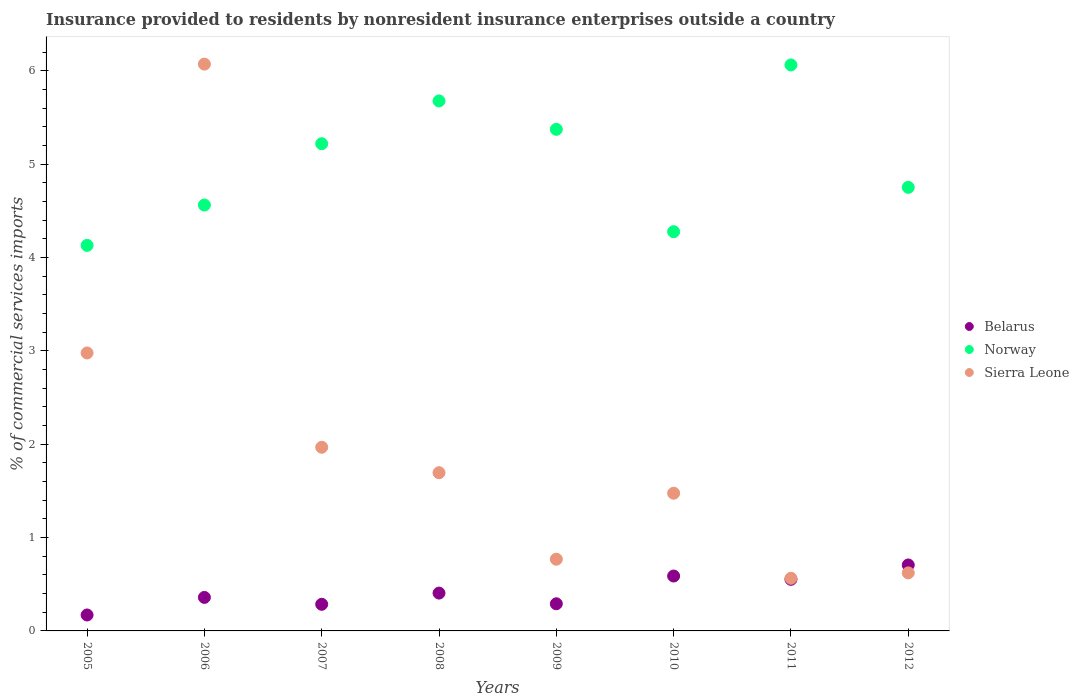Is the number of dotlines equal to the number of legend labels?
Make the answer very short. Yes. What is the Insurance provided to residents in Belarus in 2005?
Your answer should be compact. 0.17. Across all years, what is the maximum Insurance provided to residents in Sierra Leone?
Make the answer very short. 6.07. Across all years, what is the minimum Insurance provided to residents in Belarus?
Provide a succinct answer. 0.17. In which year was the Insurance provided to residents in Norway minimum?
Give a very brief answer. 2005. What is the total Insurance provided to residents in Norway in the graph?
Provide a succinct answer. 40.05. What is the difference between the Insurance provided to residents in Belarus in 2005 and that in 2006?
Give a very brief answer. -0.19. What is the difference between the Insurance provided to residents in Norway in 2006 and the Insurance provided to residents in Sierra Leone in 2005?
Your response must be concise. 1.58. What is the average Insurance provided to residents in Sierra Leone per year?
Keep it short and to the point. 2.02. In the year 2009, what is the difference between the Insurance provided to residents in Belarus and Insurance provided to residents in Sierra Leone?
Ensure brevity in your answer.  -0.48. What is the ratio of the Insurance provided to residents in Sierra Leone in 2005 to that in 2009?
Provide a succinct answer. 3.88. What is the difference between the highest and the second highest Insurance provided to residents in Norway?
Provide a succinct answer. 0.39. What is the difference between the highest and the lowest Insurance provided to residents in Norway?
Provide a short and direct response. 1.93. In how many years, is the Insurance provided to residents in Belarus greater than the average Insurance provided to residents in Belarus taken over all years?
Keep it short and to the point. 3. Is the sum of the Insurance provided to residents in Sierra Leone in 2007 and 2012 greater than the maximum Insurance provided to residents in Norway across all years?
Provide a succinct answer. No. Is the Insurance provided to residents in Norway strictly greater than the Insurance provided to residents in Sierra Leone over the years?
Your answer should be compact. No. How many years are there in the graph?
Offer a terse response. 8. Are the values on the major ticks of Y-axis written in scientific E-notation?
Your answer should be compact. No. Does the graph contain any zero values?
Keep it short and to the point. No. Does the graph contain grids?
Provide a succinct answer. No. Where does the legend appear in the graph?
Your response must be concise. Center right. How are the legend labels stacked?
Give a very brief answer. Vertical. What is the title of the graph?
Provide a succinct answer. Insurance provided to residents by nonresident insurance enterprises outside a country. Does "Guatemala" appear as one of the legend labels in the graph?
Your response must be concise. No. What is the label or title of the Y-axis?
Offer a terse response. % of commercial services imports. What is the % of commercial services imports in Belarus in 2005?
Your answer should be very brief. 0.17. What is the % of commercial services imports in Norway in 2005?
Give a very brief answer. 4.13. What is the % of commercial services imports of Sierra Leone in 2005?
Offer a very short reply. 2.98. What is the % of commercial services imports in Belarus in 2006?
Your response must be concise. 0.36. What is the % of commercial services imports in Norway in 2006?
Your response must be concise. 4.56. What is the % of commercial services imports in Sierra Leone in 2006?
Your response must be concise. 6.07. What is the % of commercial services imports in Belarus in 2007?
Make the answer very short. 0.29. What is the % of commercial services imports in Norway in 2007?
Ensure brevity in your answer.  5.22. What is the % of commercial services imports in Sierra Leone in 2007?
Keep it short and to the point. 1.97. What is the % of commercial services imports of Belarus in 2008?
Give a very brief answer. 0.41. What is the % of commercial services imports in Norway in 2008?
Your answer should be compact. 5.68. What is the % of commercial services imports in Sierra Leone in 2008?
Ensure brevity in your answer.  1.69. What is the % of commercial services imports in Belarus in 2009?
Make the answer very short. 0.29. What is the % of commercial services imports of Norway in 2009?
Offer a terse response. 5.37. What is the % of commercial services imports of Sierra Leone in 2009?
Your answer should be very brief. 0.77. What is the % of commercial services imports of Belarus in 2010?
Offer a terse response. 0.59. What is the % of commercial services imports in Norway in 2010?
Offer a very short reply. 4.28. What is the % of commercial services imports of Sierra Leone in 2010?
Give a very brief answer. 1.48. What is the % of commercial services imports of Belarus in 2011?
Ensure brevity in your answer.  0.55. What is the % of commercial services imports of Norway in 2011?
Offer a very short reply. 6.06. What is the % of commercial services imports in Sierra Leone in 2011?
Ensure brevity in your answer.  0.56. What is the % of commercial services imports in Belarus in 2012?
Your response must be concise. 0.71. What is the % of commercial services imports in Norway in 2012?
Ensure brevity in your answer.  4.75. What is the % of commercial services imports of Sierra Leone in 2012?
Offer a very short reply. 0.62. Across all years, what is the maximum % of commercial services imports in Belarus?
Make the answer very short. 0.71. Across all years, what is the maximum % of commercial services imports of Norway?
Give a very brief answer. 6.06. Across all years, what is the maximum % of commercial services imports in Sierra Leone?
Ensure brevity in your answer.  6.07. Across all years, what is the minimum % of commercial services imports of Belarus?
Provide a succinct answer. 0.17. Across all years, what is the minimum % of commercial services imports in Norway?
Provide a short and direct response. 4.13. Across all years, what is the minimum % of commercial services imports in Sierra Leone?
Offer a very short reply. 0.56. What is the total % of commercial services imports of Belarus in the graph?
Make the answer very short. 3.36. What is the total % of commercial services imports of Norway in the graph?
Ensure brevity in your answer.  40.05. What is the total % of commercial services imports of Sierra Leone in the graph?
Give a very brief answer. 16.14. What is the difference between the % of commercial services imports in Belarus in 2005 and that in 2006?
Give a very brief answer. -0.19. What is the difference between the % of commercial services imports in Norway in 2005 and that in 2006?
Provide a succinct answer. -0.43. What is the difference between the % of commercial services imports of Sierra Leone in 2005 and that in 2006?
Your response must be concise. -3.09. What is the difference between the % of commercial services imports in Belarus in 2005 and that in 2007?
Give a very brief answer. -0.11. What is the difference between the % of commercial services imports of Norway in 2005 and that in 2007?
Make the answer very short. -1.09. What is the difference between the % of commercial services imports of Belarus in 2005 and that in 2008?
Provide a succinct answer. -0.23. What is the difference between the % of commercial services imports of Norway in 2005 and that in 2008?
Your answer should be very brief. -1.55. What is the difference between the % of commercial services imports in Sierra Leone in 2005 and that in 2008?
Your answer should be compact. 1.28. What is the difference between the % of commercial services imports in Belarus in 2005 and that in 2009?
Keep it short and to the point. -0.12. What is the difference between the % of commercial services imports of Norway in 2005 and that in 2009?
Offer a terse response. -1.24. What is the difference between the % of commercial services imports in Sierra Leone in 2005 and that in 2009?
Keep it short and to the point. 2.21. What is the difference between the % of commercial services imports in Belarus in 2005 and that in 2010?
Give a very brief answer. -0.42. What is the difference between the % of commercial services imports of Norway in 2005 and that in 2010?
Your answer should be very brief. -0.15. What is the difference between the % of commercial services imports of Sierra Leone in 2005 and that in 2010?
Your response must be concise. 1.5. What is the difference between the % of commercial services imports in Belarus in 2005 and that in 2011?
Your answer should be very brief. -0.38. What is the difference between the % of commercial services imports of Norway in 2005 and that in 2011?
Offer a very short reply. -1.93. What is the difference between the % of commercial services imports of Sierra Leone in 2005 and that in 2011?
Ensure brevity in your answer.  2.41. What is the difference between the % of commercial services imports of Belarus in 2005 and that in 2012?
Ensure brevity in your answer.  -0.54. What is the difference between the % of commercial services imports in Norway in 2005 and that in 2012?
Keep it short and to the point. -0.62. What is the difference between the % of commercial services imports in Sierra Leone in 2005 and that in 2012?
Give a very brief answer. 2.36. What is the difference between the % of commercial services imports in Belarus in 2006 and that in 2007?
Your answer should be very brief. 0.07. What is the difference between the % of commercial services imports in Norway in 2006 and that in 2007?
Provide a short and direct response. -0.66. What is the difference between the % of commercial services imports in Sierra Leone in 2006 and that in 2007?
Ensure brevity in your answer.  4.1. What is the difference between the % of commercial services imports in Belarus in 2006 and that in 2008?
Provide a succinct answer. -0.05. What is the difference between the % of commercial services imports of Norway in 2006 and that in 2008?
Keep it short and to the point. -1.12. What is the difference between the % of commercial services imports of Sierra Leone in 2006 and that in 2008?
Provide a short and direct response. 4.38. What is the difference between the % of commercial services imports of Belarus in 2006 and that in 2009?
Your answer should be very brief. 0.07. What is the difference between the % of commercial services imports in Norway in 2006 and that in 2009?
Your response must be concise. -0.81. What is the difference between the % of commercial services imports in Sierra Leone in 2006 and that in 2009?
Provide a short and direct response. 5.3. What is the difference between the % of commercial services imports of Belarus in 2006 and that in 2010?
Offer a very short reply. -0.23. What is the difference between the % of commercial services imports of Norway in 2006 and that in 2010?
Your answer should be compact. 0.29. What is the difference between the % of commercial services imports in Sierra Leone in 2006 and that in 2010?
Provide a short and direct response. 4.6. What is the difference between the % of commercial services imports in Belarus in 2006 and that in 2011?
Your answer should be very brief. -0.19. What is the difference between the % of commercial services imports in Norway in 2006 and that in 2011?
Your answer should be compact. -1.5. What is the difference between the % of commercial services imports in Sierra Leone in 2006 and that in 2011?
Offer a terse response. 5.51. What is the difference between the % of commercial services imports of Belarus in 2006 and that in 2012?
Provide a succinct answer. -0.35. What is the difference between the % of commercial services imports of Norway in 2006 and that in 2012?
Give a very brief answer. -0.19. What is the difference between the % of commercial services imports in Sierra Leone in 2006 and that in 2012?
Provide a short and direct response. 5.45. What is the difference between the % of commercial services imports of Belarus in 2007 and that in 2008?
Provide a short and direct response. -0.12. What is the difference between the % of commercial services imports in Norway in 2007 and that in 2008?
Offer a very short reply. -0.46. What is the difference between the % of commercial services imports of Sierra Leone in 2007 and that in 2008?
Your response must be concise. 0.27. What is the difference between the % of commercial services imports in Belarus in 2007 and that in 2009?
Your answer should be very brief. -0.01. What is the difference between the % of commercial services imports in Norway in 2007 and that in 2009?
Your answer should be compact. -0.15. What is the difference between the % of commercial services imports in Sierra Leone in 2007 and that in 2009?
Your answer should be compact. 1.2. What is the difference between the % of commercial services imports in Belarus in 2007 and that in 2010?
Keep it short and to the point. -0.3. What is the difference between the % of commercial services imports of Norway in 2007 and that in 2010?
Provide a short and direct response. 0.94. What is the difference between the % of commercial services imports in Sierra Leone in 2007 and that in 2010?
Offer a very short reply. 0.49. What is the difference between the % of commercial services imports in Belarus in 2007 and that in 2011?
Your answer should be very brief. -0.27. What is the difference between the % of commercial services imports of Norway in 2007 and that in 2011?
Your response must be concise. -0.84. What is the difference between the % of commercial services imports of Sierra Leone in 2007 and that in 2011?
Provide a short and direct response. 1.4. What is the difference between the % of commercial services imports in Belarus in 2007 and that in 2012?
Give a very brief answer. -0.42. What is the difference between the % of commercial services imports of Norway in 2007 and that in 2012?
Your answer should be compact. 0.47. What is the difference between the % of commercial services imports in Sierra Leone in 2007 and that in 2012?
Your response must be concise. 1.35. What is the difference between the % of commercial services imports of Belarus in 2008 and that in 2009?
Your response must be concise. 0.11. What is the difference between the % of commercial services imports in Norway in 2008 and that in 2009?
Provide a succinct answer. 0.3. What is the difference between the % of commercial services imports of Sierra Leone in 2008 and that in 2009?
Provide a succinct answer. 0.93. What is the difference between the % of commercial services imports of Belarus in 2008 and that in 2010?
Make the answer very short. -0.18. What is the difference between the % of commercial services imports in Norway in 2008 and that in 2010?
Offer a very short reply. 1.4. What is the difference between the % of commercial services imports in Sierra Leone in 2008 and that in 2010?
Your answer should be compact. 0.22. What is the difference between the % of commercial services imports of Belarus in 2008 and that in 2011?
Provide a succinct answer. -0.15. What is the difference between the % of commercial services imports in Norway in 2008 and that in 2011?
Your answer should be very brief. -0.39. What is the difference between the % of commercial services imports of Sierra Leone in 2008 and that in 2011?
Make the answer very short. 1.13. What is the difference between the % of commercial services imports of Belarus in 2008 and that in 2012?
Offer a very short reply. -0.3. What is the difference between the % of commercial services imports in Norway in 2008 and that in 2012?
Provide a succinct answer. 0.93. What is the difference between the % of commercial services imports of Sierra Leone in 2008 and that in 2012?
Your response must be concise. 1.07. What is the difference between the % of commercial services imports of Belarus in 2009 and that in 2010?
Your response must be concise. -0.3. What is the difference between the % of commercial services imports of Norway in 2009 and that in 2010?
Your response must be concise. 1.1. What is the difference between the % of commercial services imports of Sierra Leone in 2009 and that in 2010?
Make the answer very short. -0.71. What is the difference between the % of commercial services imports in Belarus in 2009 and that in 2011?
Ensure brevity in your answer.  -0.26. What is the difference between the % of commercial services imports in Norway in 2009 and that in 2011?
Give a very brief answer. -0.69. What is the difference between the % of commercial services imports in Sierra Leone in 2009 and that in 2011?
Keep it short and to the point. 0.2. What is the difference between the % of commercial services imports in Belarus in 2009 and that in 2012?
Provide a short and direct response. -0.42. What is the difference between the % of commercial services imports in Norway in 2009 and that in 2012?
Your answer should be very brief. 0.62. What is the difference between the % of commercial services imports in Sierra Leone in 2009 and that in 2012?
Your response must be concise. 0.15. What is the difference between the % of commercial services imports in Belarus in 2010 and that in 2011?
Keep it short and to the point. 0.04. What is the difference between the % of commercial services imports of Norway in 2010 and that in 2011?
Ensure brevity in your answer.  -1.79. What is the difference between the % of commercial services imports of Sierra Leone in 2010 and that in 2011?
Your answer should be very brief. 0.91. What is the difference between the % of commercial services imports of Belarus in 2010 and that in 2012?
Make the answer very short. -0.12. What is the difference between the % of commercial services imports of Norway in 2010 and that in 2012?
Ensure brevity in your answer.  -0.47. What is the difference between the % of commercial services imports of Sierra Leone in 2010 and that in 2012?
Your answer should be compact. 0.85. What is the difference between the % of commercial services imports in Belarus in 2011 and that in 2012?
Make the answer very short. -0.15. What is the difference between the % of commercial services imports in Norway in 2011 and that in 2012?
Ensure brevity in your answer.  1.31. What is the difference between the % of commercial services imports in Sierra Leone in 2011 and that in 2012?
Provide a succinct answer. -0.06. What is the difference between the % of commercial services imports in Belarus in 2005 and the % of commercial services imports in Norway in 2006?
Keep it short and to the point. -4.39. What is the difference between the % of commercial services imports of Belarus in 2005 and the % of commercial services imports of Sierra Leone in 2006?
Your answer should be very brief. -5.9. What is the difference between the % of commercial services imports of Norway in 2005 and the % of commercial services imports of Sierra Leone in 2006?
Provide a short and direct response. -1.94. What is the difference between the % of commercial services imports in Belarus in 2005 and the % of commercial services imports in Norway in 2007?
Provide a succinct answer. -5.05. What is the difference between the % of commercial services imports of Belarus in 2005 and the % of commercial services imports of Sierra Leone in 2007?
Your response must be concise. -1.8. What is the difference between the % of commercial services imports of Norway in 2005 and the % of commercial services imports of Sierra Leone in 2007?
Keep it short and to the point. 2.16. What is the difference between the % of commercial services imports in Belarus in 2005 and the % of commercial services imports in Norway in 2008?
Give a very brief answer. -5.51. What is the difference between the % of commercial services imports in Belarus in 2005 and the % of commercial services imports in Sierra Leone in 2008?
Offer a very short reply. -1.52. What is the difference between the % of commercial services imports of Norway in 2005 and the % of commercial services imports of Sierra Leone in 2008?
Offer a terse response. 2.44. What is the difference between the % of commercial services imports of Belarus in 2005 and the % of commercial services imports of Norway in 2009?
Provide a succinct answer. -5.2. What is the difference between the % of commercial services imports in Belarus in 2005 and the % of commercial services imports in Sierra Leone in 2009?
Make the answer very short. -0.6. What is the difference between the % of commercial services imports of Norway in 2005 and the % of commercial services imports of Sierra Leone in 2009?
Offer a very short reply. 3.36. What is the difference between the % of commercial services imports of Belarus in 2005 and the % of commercial services imports of Norway in 2010?
Ensure brevity in your answer.  -4.11. What is the difference between the % of commercial services imports in Belarus in 2005 and the % of commercial services imports in Sierra Leone in 2010?
Keep it short and to the point. -1.3. What is the difference between the % of commercial services imports in Norway in 2005 and the % of commercial services imports in Sierra Leone in 2010?
Give a very brief answer. 2.65. What is the difference between the % of commercial services imports in Belarus in 2005 and the % of commercial services imports in Norway in 2011?
Ensure brevity in your answer.  -5.89. What is the difference between the % of commercial services imports in Belarus in 2005 and the % of commercial services imports in Sierra Leone in 2011?
Keep it short and to the point. -0.39. What is the difference between the % of commercial services imports in Norway in 2005 and the % of commercial services imports in Sierra Leone in 2011?
Give a very brief answer. 3.57. What is the difference between the % of commercial services imports of Belarus in 2005 and the % of commercial services imports of Norway in 2012?
Provide a short and direct response. -4.58. What is the difference between the % of commercial services imports in Belarus in 2005 and the % of commercial services imports in Sierra Leone in 2012?
Your answer should be compact. -0.45. What is the difference between the % of commercial services imports of Norway in 2005 and the % of commercial services imports of Sierra Leone in 2012?
Offer a terse response. 3.51. What is the difference between the % of commercial services imports in Belarus in 2006 and the % of commercial services imports in Norway in 2007?
Your response must be concise. -4.86. What is the difference between the % of commercial services imports in Belarus in 2006 and the % of commercial services imports in Sierra Leone in 2007?
Provide a succinct answer. -1.61. What is the difference between the % of commercial services imports of Norway in 2006 and the % of commercial services imports of Sierra Leone in 2007?
Give a very brief answer. 2.59. What is the difference between the % of commercial services imports in Belarus in 2006 and the % of commercial services imports in Norway in 2008?
Give a very brief answer. -5.32. What is the difference between the % of commercial services imports in Belarus in 2006 and the % of commercial services imports in Sierra Leone in 2008?
Offer a terse response. -1.34. What is the difference between the % of commercial services imports in Norway in 2006 and the % of commercial services imports in Sierra Leone in 2008?
Provide a succinct answer. 2.87. What is the difference between the % of commercial services imports of Belarus in 2006 and the % of commercial services imports of Norway in 2009?
Ensure brevity in your answer.  -5.01. What is the difference between the % of commercial services imports in Belarus in 2006 and the % of commercial services imports in Sierra Leone in 2009?
Your answer should be compact. -0.41. What is the difference between the % of commercial services imports in Norway in 2006 and the % of commercial services imports in Sierra Leone in 2009?
Provide a succinct answer. 3.79. What is the difference between the % of commercial services imports in Belarus in 2006 and the % of commercial services imports in Norway in 2010?
Ensure brevity in your answer.  -3.92. What is the difference between the % of commercial services imports in Belarus in 2006 and the % of commercial services imports in Sierra Leone in 2010?
Provide a succinct answer. -1.12. What is the difference between the % of commercial services imports in Norway in 2006 and the % of commercial services imports in Sierra Leone in 2010?
Provide a succinct answer. 3.09. What is the difference between the % of commercial services imports of Belarus in 2006 and the % of commercial services imports of Norway in 2011?
Keep it short and to the point. -5.7. What is the difference between the % of commercial services imports in Belarus in 2006 and the % of commercial services imports in Sierra Leone in 2011?
Your answer should be compact. -0.2. What is the difference between the % of commercial services imports in Norway in 2006 and the % of commercial services imports in Sierra Leone in 2011?
Give a very brief answer. 4. What is the difference between the % of commercial services imports of Belarus in 2006 and the % of commercial services imports of Norway in 2012?
Make the answer very short. -4.39. What is the difference between the % of commercial services imports of Belarus in 2006 and the % of commercial services imports of Sierra Leone in 2012?
Make the answer very short. -0.26. What is the difference between the % of commercial services imports of Norway in 2006 and the % of commercial services imports of Sierra Leone in 2012?
Keep it short and to the point. 3.94. What is the difference between the % of commercial services imports of Belarus in 2007 and the % of commercial services imports of Norway in 2008?
Make the answer very short. -5.39. What is the difference between the % of commercial services imports in Belarus in 2007 and the % of commercial services imports in Sierra Leone in 2008?
Your response must be concise. -1.41. What is the difference between the % of commercial services imports in Norway in 2007 and the % of commercial services imports in Sierra Leone in 2008?
Offer a very short reply. 3.52. What is the difference between the % of commercial services imports in Belarus in 2007 and the % of commercial services imports in Norway in 2009?
Give a very brief answer. -5.09. What is the difference between the % of commercial services imports in Belarus in 2007 and the % of commercial services imports in Sierra Leone in 2009?
Your response must be concise. -0.48. What is the difference between the % of commercial services imports of Norway in 2007 and the % of commercial services imports of Sierra Leone in 2009?
Offer a terse response. 4.45. What is the difference between the % of commercial services imports of Belarus in 2007 and the % of commercial services imports of Norway in 2010?
Give a very brief answer. -3.99. What is the difference between the % of commercial services imports of Belarus in 2007 and the % of commercial services imports of Sierra Leone in 2010?
Provide a succinct answer. -1.19. What is the difference between the % of commercial services imports in Norway in 2007 and the % of commercial services imports in Sierra Leone in 2010?
Provide a short and direct response. 3.74. What is the difference between the % of commercial services imports in Belarus in 2007 and the % of commercial services imports in Norway in 2011?
Provide a short and direct response. -5.78. What is the difference between the % of commercial services imports in Belarus in 2007 and the % of commercial services imports in Sierra Leone in 2011?
Make the answer very short. -0.28. What is the difference between the % of commercial services imports in Norway in 2007 and the % of commercial services imports in Sierra Leone in 2011?
Offer a terse response. 4.66. What is the difference between the % of commercial services imports of Belarus in 2007 and the % of commercial services imports of Norway in 2012?
Keep it short and to the point. -4.47. What is the difference between the % of commercial services imports of Belarus in 2007 and the % of commercial services imports of Sierra Leone in 2012?
Offer a very short reply. -0.34. What is the difference between the % of commercial services imports in Norway in 2007 and the % of commercial services imports in Sierra Leone in 2012?
Your response must be concise. 4.6. What is the difference between the % of commercial services imports in Belarus in 2008 and the % of commercial services imports in Norway in 2009?
Give a very brief answer. -4.97. What is the difference between the % of commercial services imports in Belarus in 2008 and the % of commercial services imports in Sierra Leone in 2009?
Offer a very short reply. -0.36. What is the difference between the % of commercial services imports of Norway in 2008 and the % of commercial services imports of Sierra Leone in 2009?
Offer a very short reply. 4.91. What is the difference between the % of commercial services imports of Belarus in 2008 and the % of commercial services imports of Norway in 2010?
Provide a short and direct response. -3.87. What is the difference between the % of commercial services imports of Belarus in 2008 and the % of commercial services imports of Sierra Leone in 2010?
Offer a very short reply. -1.07. What is the difference between the % of commercial services imports in Norway in 2008 and the % of commercial services imports in Sierra Leone in 2010?
Keep it short and to the point. 4.2. What is the difference between the % of commercial services imports in Belarus in 2008 and the % of commercial services imports in Norway in 2011?
Your answer should be very brief. -5.66. What is the difference between the % of commercial services imports of Belarus in 2008 and the % of commercial services imports of Sierra Leone in 2011?
Provide a short and direct response. -0.16. What is the difference between the % of commercial services imports of Norway in 2008 and the % of commercial services imports of Sierra Leone in 2011?
Offer a very short reply. 5.11. What is the difference between the % of commercial services imports in Belarus in 2008 and the % of commercial services imports in Norway in 2012?
Offer a very short reply. -4.35. What is the difference between the % of commercial services imports in Belarus in 2008 and the % of commercial services imports in Sierra Leone in 2012?
Your response must be concise. -0.22. What is the difference between the % of commercial services imports in Norway in 2008 and the % of commercial services imports in Sierra Leone in 2012?
Provide a short and direct response. 5.06. What is the difference between the % of commercial services imports of Belarus in 2009 and the % of commercial services imports of Norway in 2010?
Give a very brief answer. -3.99. What is the difference between the % of commercial services imports in Belarus in 2009 and the % of commercial services imports in Sierra Leone in 2010?
Your answer should be compact. -1.18. What is the difference between the % of commercial services imports of Norway in 2009 and the % of commercial services imports of Sierra Leone in 2010?
Offer a terse response. 3.9. What is the difference between the % of commercial services imports in Belarus in 2009 and the % of commercial services imports in Norway in 2011?
Provide a succinct answer. -5.77. What is the difference between the % of commercial services imports in Belarus in 2009 and the % of commercial services imports in Sierra Leone in 2011?
Your answer should be very brief. -0.27. What is the difference between the % of commercial services imports in Norway in 2009 and the % of commercial services imports in Sierra Leone in 2011?
Your answer should be compact. 4.81. What is the difference between the % of commercial services imports in Belarus in 2009 and the % of commercial services imports in Norway in 2012?
Make the answer very short. -4.46. What is the difference between the % of commercial services imports in Belarus in 2009 and the % of commercial services imports in Sierra Leone in 2012?
Offer a terse response. -0.33. What is the difference between the % of commercial services imports of Norway in 2009 and the % of commercial services imports of Sierra Leone in 2012?
Offer a terse response. 4.75. What is the difference between the % of commercial services imports in Belarus in 2010 and the % of commercial services imports in Norway in 2011?
Offer a terse response. -5.48. What is the difference between the % of commercial services imports in Belarus in 2010 and the % of commercial services imports in Sierra Leone in 2011?
Keep it short and to the point. 0.02. What is the difference between the % of commercial services imports of Norway in 2010 and the % of commercial services imports of Sierra Leone in 2011?
Ensure brevity in your answer.  3.71. What is the difference between the % of commercial services imports in Belarus in 2010 and the % of commercial services imports in Norway in 2012?
Ensure brevity in your answer.  -4.16. What is the difference between the % of commercial services imports of Belarus in 2010 and the % of commercial services imports of Sierra Leone in 2012?
Offer a very short reply. -0.03. What is the difference between the % of commercial services imports in Norway in 2010 and the % of commercial services imports in Sierra Leone in 2012?
Your answer should be very brief. 3.65. What is the difference between the % of commercial services imports of Belarus in 2011 and the % of commercial services imports of Norway in 2012?
Provide a short and direct response. -4.2. What is the difference between the % of commercial services imports in Belarus in 2011 and the % of commercial services imports in Sierra Leone in 2012?
Your answer should be compact. -0.07. What is the difference between the % of commercial services imports in Norway in 2011 and the % of commercial services imports in Sierra Leone in 2012?
Offer a very short reply. 5.44. What is the average % of commercial services imports of Belarus per year?
Give a very brief answer. 0.42. What is the average % of commercial services imports in Norway per year?
Ensure brevity in your answer.  5.01. What is the average % of commercial services imports of Sierra Leone per year?
Keep it short and to the point. 2.02. In the year 2005, what is the difference between the % of commercial services imports of Belarus and % of commercial services imports of Norway?
Offer a terse response. -3.96. In the year 2005, what is the difference between the % of commercial services imports in Belarus and % of commercial services imports in Sierra Leone?
Your response must be concise. -2.81. In the year 2005, what is the difference between the % of commercial services imports in Norway and % of commercial services imports in Sierra Leone?
Make the answer very short. 1.15. In the year 2006, what is the difference between the % of commercial services imports in Belarus and % of commercial services imports in Norway?
Your answer should be compact. -4.2. In the year 2006, what is the difference between the % of commercial services imports in Belarus and % of commercial services imports in Sierra Leone?
Your answer should be compact. -5.71. In the year 2006, what is the difference between the % of commercial services imports of Norway and % of commercial services imports of Sierra Leone?
Your answer should be very brief. -1.51. In the year 2007, what is the difference between the % of commercial services imports of Belarus and % of commercial services imports of Norway?
Keep it short and to the point. -4.93. In the year 2007, what is the difference between the % of commercial services imports in Belarus and % of commercial services imports in Sierra Leone?
Offer a very short reply. -1.68. In the year 2007, what is the difference between the % of commercial services imports in Norway and % of commercial services imports in Sierra Leone?
Your answer should be very brief. 3.25. In the year 2008, what is the difference between the % of commercial services imports of Belarus and % of commercial services imports of Norway?
Offer a very short reply. -5.27. In the year 2008, what is the difference between the % of commercial services imports of Belarus and % of commercial services imports of Sierra Leone?
Provide a short and direct response. -1.29. In the year 2008, what is the difference between the % of commercial services imports of Norway and % of commercial services imports of Sierra Leone?
Your answer should be compact. 3.98. In the year 2009, what is the difference between the % of commercial services imports of Belarus and % of commercial services imports of Norway?
Provide a succinct answer. -5.08. In the year 2009, what is the difference between the % of commercial services imports in Belarus and % of commercial services imports in Sierra Leone?
Your answer should be compact. -0.48. In the year 2009, what is the difference between the % of commercial services imports of Norway and % of commercial services imports of Sierra Leone?
Your answer should be very brief. 4.6. In the year 2010, what is the difference between the % of commercial services imports in Belarus and % of commercial services imports in Norway?
Make the answer very short. -3.69. In the year 2010, what is the difference between the % of commercial services imports in Belarus and % of commercial services imports in Sierra Leone?
Keep it short and to the point. -0.89. In the year 2010, what is the difference between the % of commercial services imports in Norway and % of commercial services imports in Sierra Leone?
Offer a very short reply. 2.8. In the year 2011, what is the difference between the % of commercial services imports of Belarus and % of commercial services imports of Norway?
Provide a succinct answer. -5.51. In the year 2011, what is the difference between the % of commercial services imports of Belarus and % of commercial services imports of Sierra Leone?
Offer a terse response. -0.01. In the year 2011, what is the difference between the % of commercial services imports of Norway and % of commercial services imports of Sierra Leone?
Your answer should be compact. 5.5. In the year 2012, what is the difference between the % of commercial services imports of Belarus and % of commercial services imports of Norway?
Keep it short and to the point. -4.05. In the year 2012, what is the difference between the % of commercial services imports in Belarus and % of commercial services imports in Sierra Leone?
Your answer should be compact. 0.08. In the year 2012, what is the difference between the % of commercial services imports of Norway and % of commercial services imports of Sierra Leone?
Your response must be concise. 4.13. What is the ratio of the % of commercial services imports in Belarus in 2005 to that in 2006?
Give a very brief answer. 0.48. What is the ratio of the % of commercial services imports of Norway in 2005 to that in 2006?
Keep it short and to the point. 0.91. What is the ratio of the % of commercial services imports in Sierra Leone in 2005 to that in 2006?
Provide a short and direct response. 0.49. What is the ratio of the % of commercial services imports of Belarus in 2005 to that in 2007?
Provide a succinct answer. 0.6. What is the ratio of the % of commercial services imports in Norway in 2005 to that in 2007?
Offer a very short reply. 0.79. What is the ratio of the % of commercial services imports in Sierra Leone in 2005 to that in 2007?
Ensure brevity in your answer.  1.51. What is the ratio of the % of commercial services imports of Belarus in 2005 to that in 2008?
Provide a succinct answer. 0.42. What is the ratio of the % of commercial services imports in Norway in 2005 to that in 2008?
Provide a succinct answer. 0.73. What is the ratio of the % of commercial services imports in Sierra Leone in 2005 to that in 2008?
Offer a very short reply. 1.76. What is the ratio of the % of commercial services imports in Belarus in 2005 to that in 2009?
Your response must be concise. 0.59. What is the ratio of the % of commercial services imports in Norway in 2005 to that in 2009?
Give a very brief answer. 0.77. What is the ratio of the % of commercial services imports in Sierra Leone in 2005 to that in 2009?
Provide a short and direct response. 3.88. What is the ratio of the % of commercial services imports of Belarus in 2005 to that in 2010?
Offer a terse response. 0.29. What is the ratio of the % of commercial services imports of Norway in 2005 to that in 2010?
Your answer should be very brief. 0.97. What is the ratio of the % of commercial services imports in Sierra Leone in 2005 to that in 2010?
Provide a succinct answer. 2.02. What is the ratio of the % of commercial services imports of Belarus in 2005 to that in 2011?
Provide a succinct answer. 0.31. What is the ratio of the % of commercial services imports of Norway in 2005 to that in 2011?
Offer a very short reply. 0.68. What is the ratio of the % of commercial services imports in Sierra Leone in 2005 to that in 2011?
Keep it short and to the point. 5.28. What is the ratio of the % of commercial services imports in Belarus in 2005 to that in 2012?
Offer a very short reply. 0.24. What is the ratio of the % of commercial services imports of Norway in 2005 to that in 2012?
Your answer should be very brief. 0.87. What is the ratio of the % of commercial services imports in Sierra Leone in 2005 to that in 2012?
Offer a terse response. 4.79. What is the ratio of the % of commercial services imports of Belarus in 2006 to that in 2007?
Offer a terse response. 1.26. What is the ratio of the % of commercial services imports of Norway in 2006 to that in 2007?
Give a very brief answer. 0.87. What is the ratio of the % of commercial services imports in Sierra Leone in 2006 to that in 2007?
Your answer should be compact. 3.09. What is the ratio of the % of commercial services imports in Belarus in 2006 to that in 2008?
Provide a succinct answer. 0.89. What is the ratio of the % of commercial services imports in Norway in 2006 to that in 2008?
Provide a short and direct response. 0.8. What is the ratio of the % of commercial services imports of Sierra Leone in 2006 to that in 2008?
Make the answer very short. 3.58. What is the ratio of the % of commercial services imports of Belarus in 2006 to that in 2009?
Offer a terse response. 1.24. What is the ratio of the % of commercial services imports of Norway in 2006 to that in 2009?
Provide a short and direct response. 0.85. What is the ratio of the % of commercial services imports of Sierra Leone in 2006 to that in 2009?
Your response must be concise. 7.9. What is the ratio of the % of commercial services imports in Belarus in 2006 to that in 2010?
Your answer should be very brief. 0.61. What is the ratio of the % of commercial services imports in Norway in 2006 to that in 2010?
Your answer should be compact. 1.07. What is the ratio of the % of commercial services imports in Sierra Leone in 2006 to that in 2010?
Your answer should be compact. 4.12. What is the ratio of the % of commercial services imports of Belarus in 2006 to that in 2011?
Your answer should be compact. 0.65. What is the ratio of the % of commercial services imports of Norway in 2006 to that in 2011?
Offer a terse response. 0.75. What is the ratio of the % of commercial services imports of Sierra Leone in 2006 to that in 2011?
Make the answer very short. 10.77. What is the ratio of the % of commercial services imports of Belarus in 2006 to that in 2012?
Provide a short and direct response. 0.51. What is the ratio of the % of commercial services imports of Norway in 2006 to that in 2012?
Your answer should be very brief. 0.96. What is the ratio of the % of commercial services imports in Sierra Leone in 2006 to that in 2012?
Provide a succinct answer. 9.76. What is the ratio of the % of commercial services imports of Belarus in 2007 to that in 2008?
Provide a short and direct response. 0.7. What is the ratio of the % of commercial services imports in Norway in 2007 to that in 2008?
Provide a short and direct response. 0.92. What is the ratio of the % of commercial services imports of Sierra Leone in 2007 to that in 2008?
Provide a short and direct response. 1.16. What is the ratio of the % of commercial services imports of Belarus in 2007 to that in 2009?
Offer a very short reply. 0.98. What is the ratio of the % of commercial services imports of Norway in 2007 to that in 2009?
Give a very brief answer. 0.97. What is the ratio of the % of commercial services imports of Sierra Leone in 2007 to that in 2009?
Your response must be concise. 2.56. What is the ratio of the % of commercial services imports in Belarus in 2007 to that in 2010?
Offer a very short reply. 0.48. What is the ratio of the % of commercial services imports of Norway in 2007 to that in 2010?
Ensure brevity in your answer.  1.22. What is the ratio of the % of commercial services imports in Sierra Leone in 2007 to that in 2010?
Provide a succinct answer. 1.33. What is the ratio of the % of commercial services imports of Belarus in 2007 to that in 2011?
Ensure brevity in your answer.  0.52. What is the ratio of the % of commercial services imports in Norway in 2007 to that in 2011?
Your response must be concise. 0.86. What is the ratio of the % of commercial services imports of Sierra Leone in 2007 to that in 2011?
Your response must be concise. 3.49. What is the ratio of the % of commercial services imports of Belarus in 2007 to that in 2012?
Provide a succinct answer. 0.4. What is the ratio of the % of commercial services imports in Norway in 2007 to that in 2012?
Provide a short and direct response. 1.1. What is the ratio of the % of commercial services imports in Sierra Leone in 2007 to that in 2012?
Offer a terse response. 3.16. What is the ratio of the % of commercial services imports of Belarus in 2008 to that in 2009?
Provide a succinct answer. 1.39. What is the ratio of the % of commercial services imports in Norway in 2008 to that in 2009?
Your answer should be very brief. 1.06. What is the ratio of the % of commercial services imports in Sierra Leone in 2008 to that in 2009?
Your answer should be very brief. 2.21. What is the ratio of the % of commercial services imports of Belarus in 2008 to that in 2010?
Your answer should be very brief. 0.69. What is the ratio of the % of commercial services imports of Norway in 2008 to that in 2010?
Offer a very short reply. 1.33. What is the ratio of the % of commercial services imports in Sierra Leone in 2008 to that in 2010?
Make the answer very short. 1.15. What is the ratio of the % of commercial services imports in Belarus in 2008 to that in 2011?
Offer a terse response. 0.73. What is the ratio of the % of commercial services imports in Norway in 2008 to that in 2011?
Your response must be concise. 0.94. What is the ratio of the % of commercial services imports of Sierra Leone in 2008 to that in 2011?
Your answer should be compact. 3. What is the ratio of the % of commercial services imports of Belarus in 2008 to that in 2012?
Your response must be concise. 0.57. What is the ratio of the % of commercial services imports in Norway in 2008 to that in 2012?
Ensure brevity in your answer.  1.19. What is the ratio of the % of commercial services imports of Sierra Leone in 2008 to that in 2012?
Make the answer very short. 2.73. What is the ratio of the % of commercial services imports in Belarus in 2009 to that in 2010?
Offer a terse response. 0.49. What is the ratio of the % of commercial services imports in Norway in 2009 to that in 2010?
Provide a succinct answer. 1.26. What is the ratio of the % of commercial services imports of Sierra Leone in 2009 to that in 2010?
Your answer should be compact. 0.52. What is the ratio of the % of commercial services imports in Belarus in 2009 to that in 2011?
Give a very brief answer. 0.53. What is the ratio of the % of commercial services imports in Norway in 2009 to that in 2011?
Provide a succinct answer. 0.89. What is the ratio of the % of commercial services imports of Sierra Leone in 2009 to that in 2011?
Ensure brevity in your answer.  1.36. What is the ratio of the % of commercial services imports of Belarus in 2009 to that in 2012?
Provide a succinct answer. 0.41. What is the ratio of the % of commercial services imports in Norway in 2009 to that in 2012?
Give a very brief answer. 1.13. What is the ratio of the % of commercial services imports in Sierra Leone in 2009 to that in 2012?
Your response must be concise. 1.24. What is the ratio of the % of commercial services imports of Belarus in 2010 to that in 2011?
Your answer should be very brief. 1.06. What is the ratio of the % of commercial services imports of Norway in 2010 to that in 2011?
Make the answer very short. 0.71. What is the ratio of the % of commercial services imports in Sierra Leone in 2010 to that in 2011?
Ensure brevity in your answer.  2.62. What is the ratio of the % of commercial services imports of Belarus in 2010 to that in 2012?
Offer a very short reply. 0.83. What is the ratio of the % of commercial services imports in Norway in 2010 to that in 2012?
Ensure brevity in your answer.  0.9. What is the ratio of the % of commercial services imports in Sierra Leone in 2010 to that in 2012?
Your answer should be very brief. 2.37. What is the ratio of the % of commercial services imports of Belarus in 2011 to that in 2012?
Ensure brevity in your answer.  0.78. What is the ratio of the % of commercial services imports of Norway in 2011 to that in 2012?
Offer a terse response. 1.28. What is the ratio of the % of commercial services imports in Sierra Leone in 2011 to that in 2012?
Your response must be concise. 0.91. What is the difference between the highest and the second highest % of commercial services imports in Belarus?
Your answer should be very brief. 0.12. What is the difference between the highest and the second highest % of commercial services imports in Norway?
Offer a terse response. 0.39. What is the difference between the highest and the second highest % of commercial services imports of Sierra Leone?
Offer a terse response. 3.09. What is the difference between the highest and the lowest % of commercial services imports in Belarus?
Ensure brevity in your answer.  0.54. What is the difference between the highest and the lowest % of commercial services imports in Norway?
Keep it short and to the point. 1.93. What is the difference between the highest and the lowest % of commercial services imports of Sierra Leone?
Offer a very short reply. 5.51. 